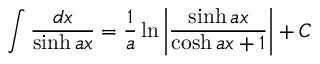<formula> <loc_0><loc_0><loc_500><loc_500>\int { \frac { d x } { \sinh a x } } = { \frac { 1 } { a } } \ln \left | { \frac { \sinh a x } { \cosh a x + 1 } } \right | + C</formula> 